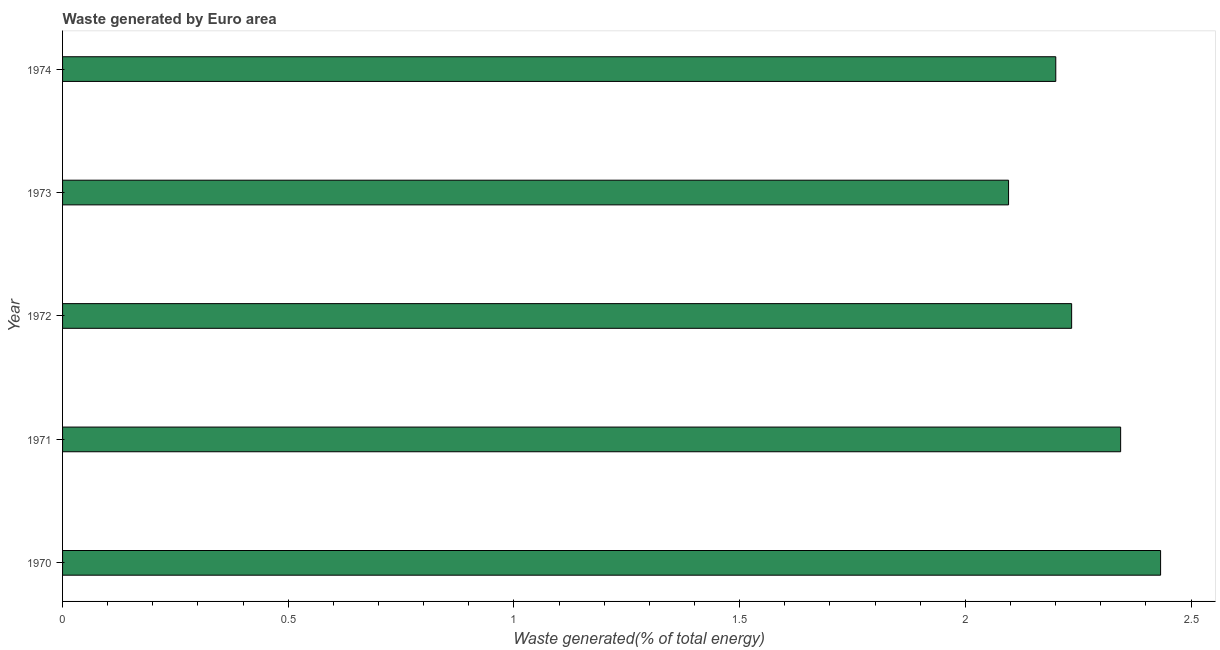What is the title of the graph?
Your answer should be very brief. Waste generated by Euro area. What is the label or title of the X-axis?
Ensure brevity in your answer.  Waste generated(% of total energy). What is the label or title of the Y-axis?
Make the answer very short. Year. What is the amount of waste generated in 1974?
Ensure brevity in your answer.  2.2. Across all years, what is the maximum amount of waste generated?
Offer a very short reply. 2.43. Across all years, what is the minimum amount of waste generated?
Ensure brevity in your answer.  2.1. In which year was the amount of waste generated maximum?
Your answer should be compact. 1970. What is the sum of the amount of waste generated?
Your answer should be compact. 11.31. What is the difference between the amount of waste generated in 1971 and 1972?
Offer a terse response. 0.11. What is the average amount of waste generated per year?
Provide a short and direct response. 2.26. What is the median amount of waste generated?
Make the answer very short. 2.24. Do a majority of the years between 1974 and 1973 (inclusive) have amount of waste generated greater than 0.3 %?
Offer a terse response. No. Is the difference between the amount of waste generated in 1970 and 1974 greater than the difference between any two years?
Offer a terse response. No. What is the difference between the highest and the second highest amount of waste generated?
Provide a succinct answer. 0.09. What is the difference between the highest and the lowest amount of waste generated?
Keep it short and to the point. 0.34. How many years are there in the graph?
Your response must be concise. 5. What is the difference between two consecutive major ticks on the X-axis?
Keep it short and to the point. 0.5. What is the Waste generated(% of total energy) of 1970?
Your answer should be compact. 2.43. What is the Waste generated(% of total energy) in 1971?
Ensure brevity in your answer.  2.34. What is the Waste generated(% of total energy) of 1972?
Keep it short and to the point. 2.24. What is the Waste generated(% of total energy) of 1973?
Offer a terse response. 2.1. What is the Waste generated(% of total energy) in 1974?
Offer a terse response. 2.2. What is the difference between the Waste generated(% of total energy) in 1970 and 1971?
Offer a very short reply. 0.09. What is the difference between the Waste generated(% of total energy) in 1970 and 1972?
Ensure brevity in your answer.  0.2. What is the difference between the Waste generated(% of total energy) in 1970 and 1973?
Your response must be concise. 0.34. What is the difference between the Waste generated(% of total energy) in 1970 and 1974?
Ensure brevity in your answer.  0.23. What is the difference between the Waste generated(% of total energy) in 1971 and 1972?
Provide a short and direct response. 0.11. What is the difference between the Waste generated(% of total energy) in 1971 and 1973?
Your answer should be very brief. 0.25. What is the difference between the Waste generated(% of total energy) in 1971 and 1974?
Make the answer very short. 0.14. What is the difference between the Waste generated(% of total energy) in 1972 and 1973?
Offer a very short reply. 0.14. What is the difference between the Waste generated(% of total energy) in 1972 and 1974?
Ensure brevity in your answer.  0.04. What is the difference between the Waste generated(% of total energy) in 1973 and 1974?
Offer a terse response. -0.1. What is the ratio of the Waste generated(% of total energy) in 1970 to that in 1971?
Keep it short and to the point. 1.04. What is the ratio of the Waste generated(% of total energy) in 1970 to that in 1972?
Provide a succinct answer. 1.09. What is the ratio of the Waste generated(% of total energy) in 1970 to that in 1973?
Ensure brevity in your answer.  1.16. What is the ratio of the Waste generated(% of total energy) in 1970 to that in 1974?
Your answer should be very brief. 1.11. What is the ratio of the Waste generated(% of total energy) in 1971 to that in 1972?
Offer a very short reply. 1.05. What is the ratio of the Waste generated(% of total energy) in 1971 to that in 1973?
Provide a short and direct response. 1.12. What is the ratio of the Waste generated(% of total energy) in 1971 to that in 1974?
Give a very brief answer. 1.06. What is the ratio of the Waste generated(% of total energy) in 1972 to that in 1973?
Offer a very short reply. 1.07. What is the ratio of the Waste generated(% of total energy) in 1972 to that in 1974?
Your response must be concise. 1.02. What is the ratio of the Waste generated(% of total energy) in 1973 to that in 1974?
Give a very brief answer. 0.95. 